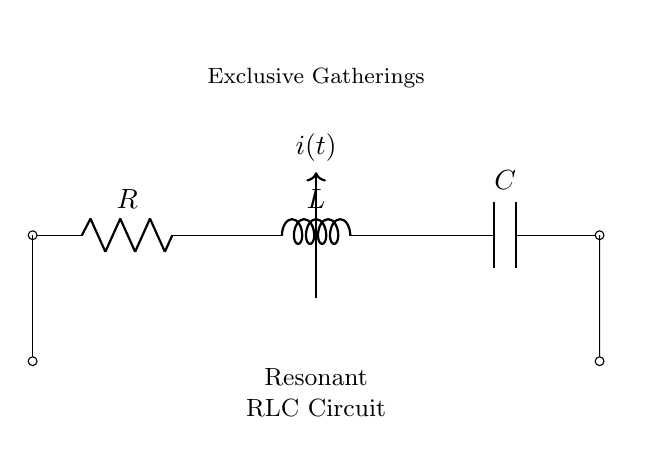What components are present in the circuit? The circuit consists of a resistor, an inductor, and a capacitor, which are the three essential components of an RLC circuit.
Answer: Resistor, Inductor, Capacitor What is the connection type between the components? The components are connected in series, as indicated by the single line connecting them in a sequential manner without branching.
Answer: Series What type of circuit is represented here? The circuit is a resonant RLC circuit because it includes a resistor, inductor, and capacitor, which resonates when the right frequency is applied.
Answer: Resonant RLC Circuit What is the importance of resonance in this circuit? Resonance allows the circuit to oscillate at a specific frequency, enhancing its response and interaction, which is crucial for applications in kinetic art.
Answer: Enhances response What does the current symbol represent in this diagram? The current symbol indicates the flow of electric current, which is essential for the operation of the circuit and affects how the art piece behaves.
Answer: Flow of current What effect does varying the resistance have on the circuit? Varying the resistance changes the damping of the circuit's oscillation, impacting how long the circuit will oscillate and thus affecting the kinetic art's visual behavior.
Answer: Affects damping 